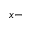<formula> <loc_0><loc_0><loc_500><loc_500>x -</formula> 